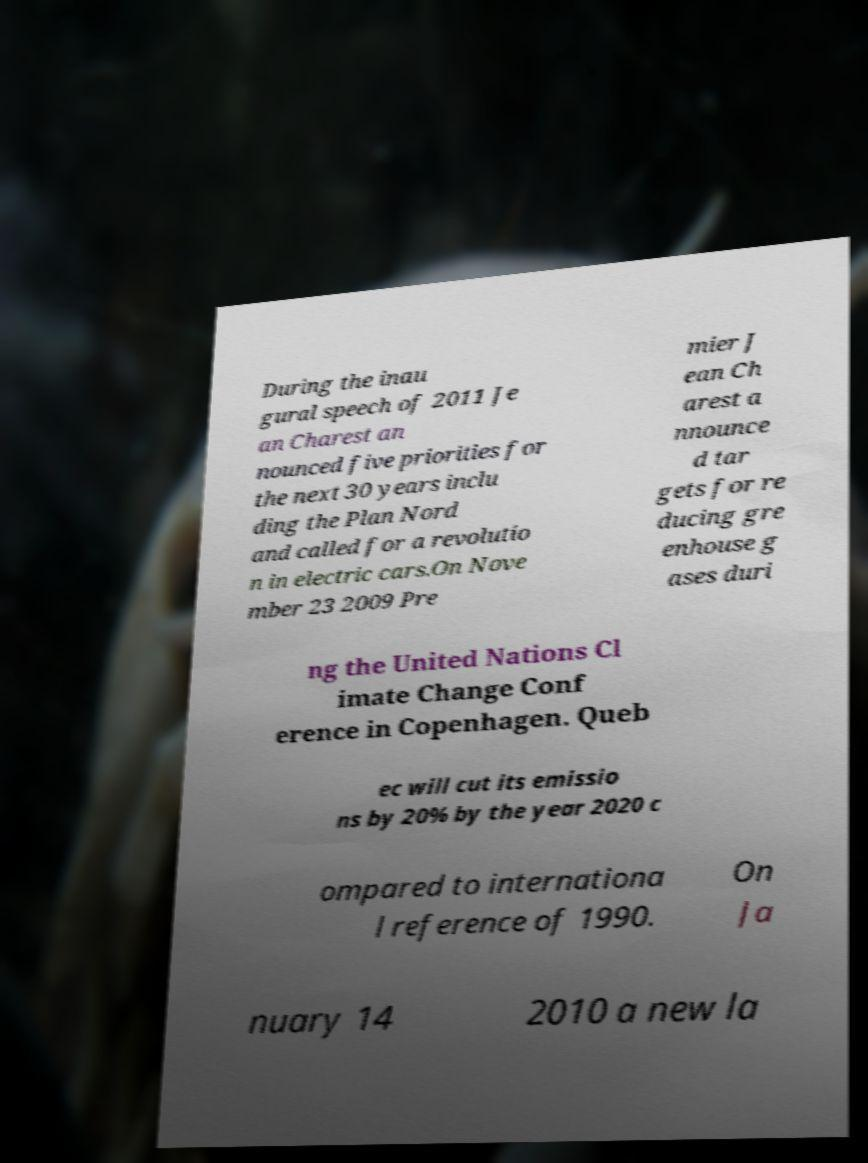Could you assist in decoding the text presented in this image and type it out clearly? During the inau gural speech of 2011 Je an Charest an nounced five priorities for the next 30 years inclu ding the Plan Nord and called for a revolutio n in electric cars.On Nove mber 23 2009 Pre mier J ean Ch arest a nnounce d tar gets for re ducing gre enhouse g ases duri ng the United Nations Cl imate Change Conf erence in Copenhagen. Queb ec will cut its emissio ns by 20% by the year 2020 c ompared to internationa l reference of 1990. On Ja nuary 14 2010 a new la 